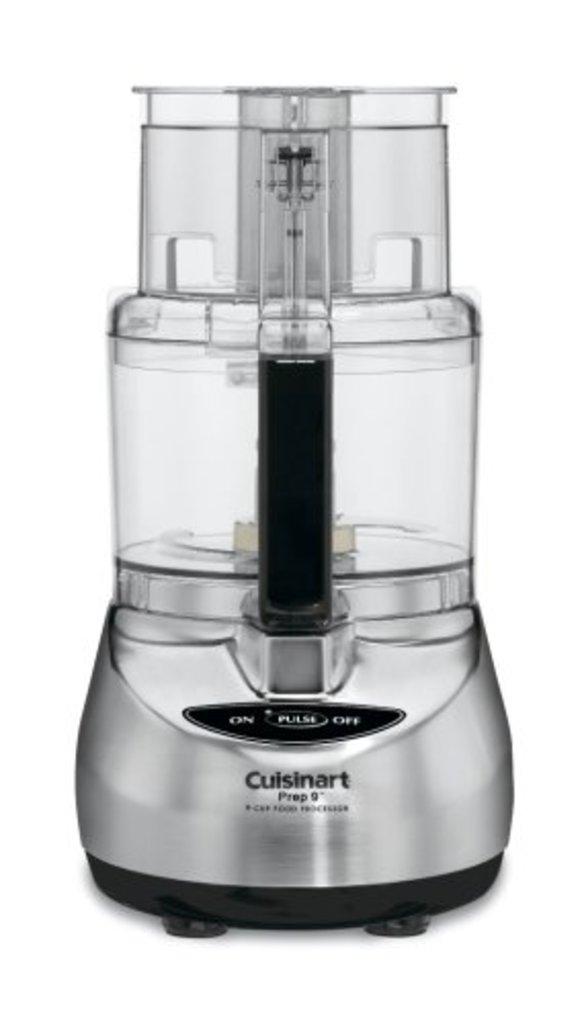What brand is this appliance?
Your response must be concise. Cuisinart. What is the button in the middle?
Offer a terse response. Pulse. 